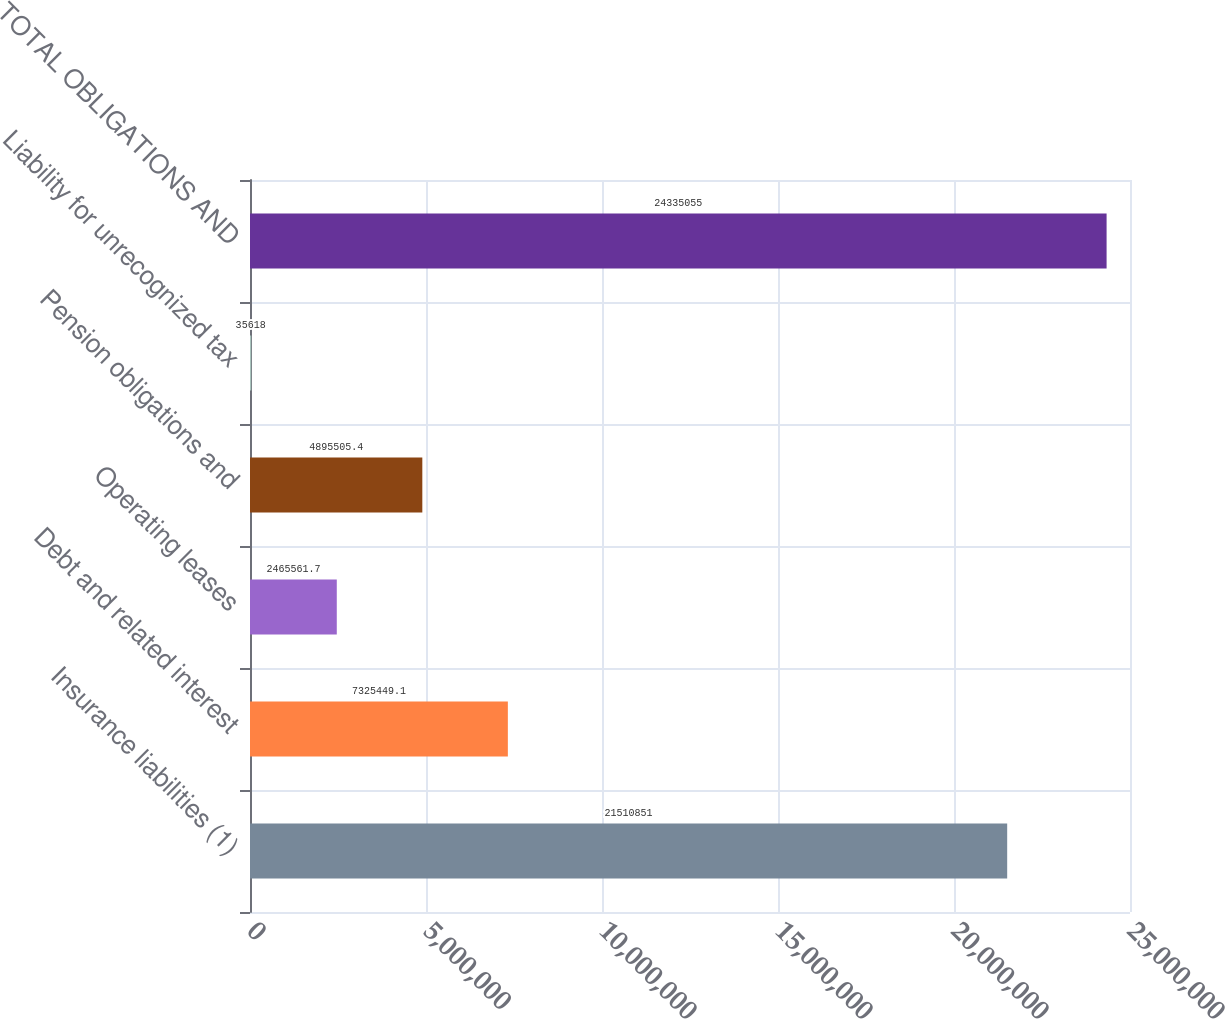<chart> <loc_0><loc_0><loc_500><loc_500><bar_chart><fcel>Insurance liabilities (1)<fcel>Debt and related interest<fcel>Operating leases<fcel>Pension obligations and<fcel>Liability for unrecognized tax<fcel>TOTAL OBLIGATIONS AND<nl><fcel>2.15109e+07<fcel>7.32545e+06<fcel>2.46556e+06<fcel>4.89551e+06<fcel>35618<fcel>2.43351e+07<nl></chart> 